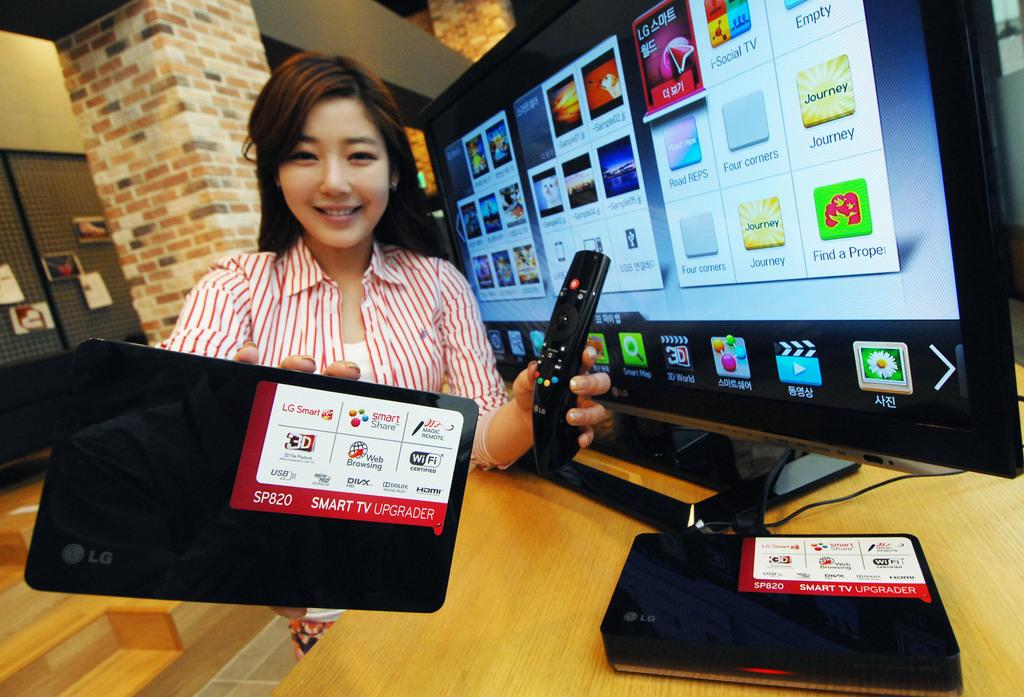<image>
Relay a brief, clear account of the picture shown. Two devices that say smart tv upgraders in front of a tv. 